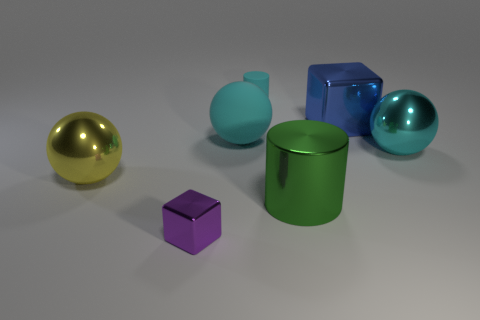Subtract all rubber spheres. How many spheres are left? 2 Subtract 1 cylinders. How many cylinders are left? 1 Subtract all green cubes. How many cyan balls are left? 2 Subtract all green cylinders. How many cylinders are left? 1 Add 3 cylinders. How many objects exist? 10 Subtract all balls. How many objects are left? 4 Add 2 green cylinders. How many green cylinders exist? 3 Subtract 0 brown cubes. How many objects are left? 7 Subtract all green cylinders. Subtract all purple spheres. How many cylinders are left? 1 Subtract all large cyan matte spheres. Subtract all blue cubes. How many objects are left? 5 